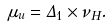Convert formula to latex. <formula><loc_0><loc_0><loc_500><loc_500>\mu _ { u } = \Delta _ { 1 } \times \nu _ { H } .</formula> 